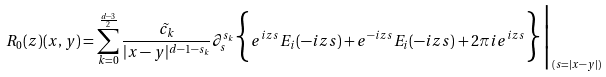<formula> <loc_0><loc_0><loc_500><loc_500>R _ { 0 } ( z ) ( x , y ) = \sum _ { k = 0 } ^ { \frac { d - 3 } { 2 } } \frac { \tilde { c _ { k } } } { | x - y | ^ { d - 1 - s _ { k } } } \partial _ { s } ^ { s _ { k } } \Big \{ e ^ { i z s } E _ { i } ( - i z s ) + e ^ { - i z s } E _ { i } ( - i z s ) + 2 \pi i e ^ { i z s } \Big \} \Big | _ { ( s = | x - y | ) }</formula> 